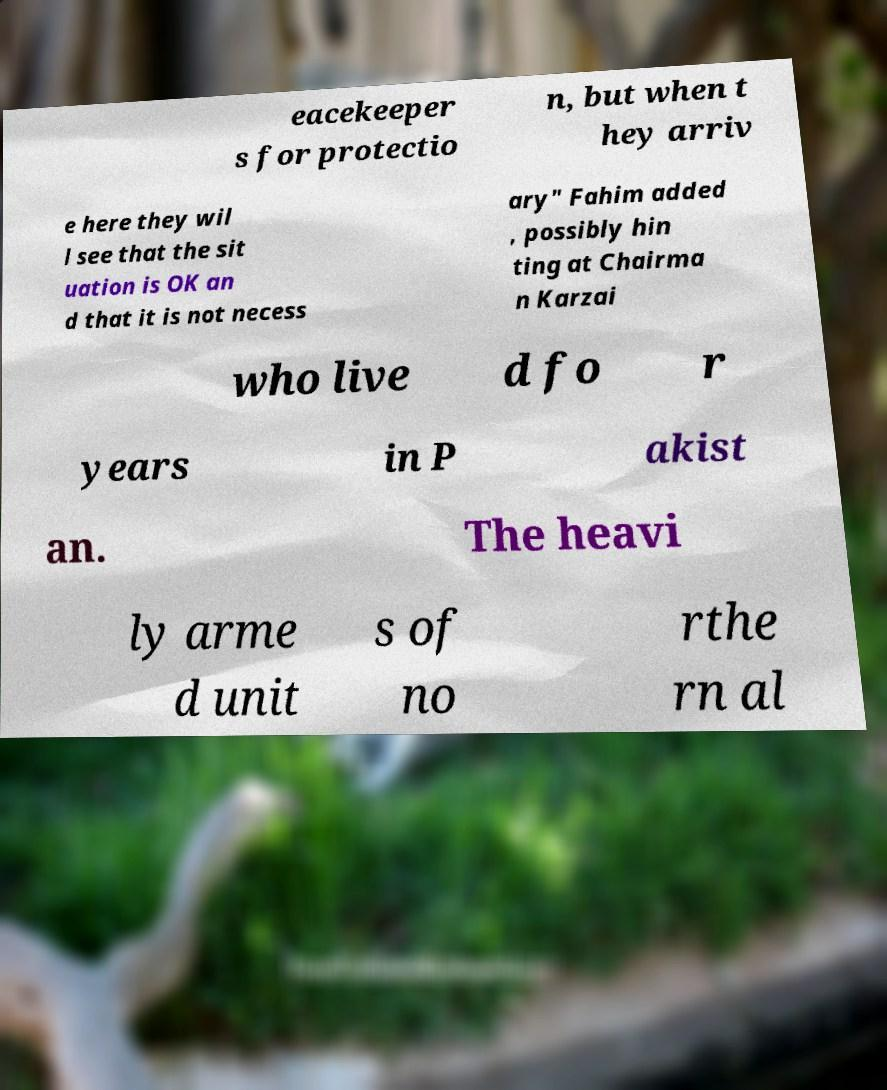Please identify and transcribe the text found in this image. eacekeeper s for protectio n, but when t hey arriv e here they wil l see that the sit uation is OK an d that it is not necess ary" Fahim added , possibly hin ting at Chairma n Karzai who live d fo r years in P akist an. The heavi ly arme d unit s of no rthe rn al 